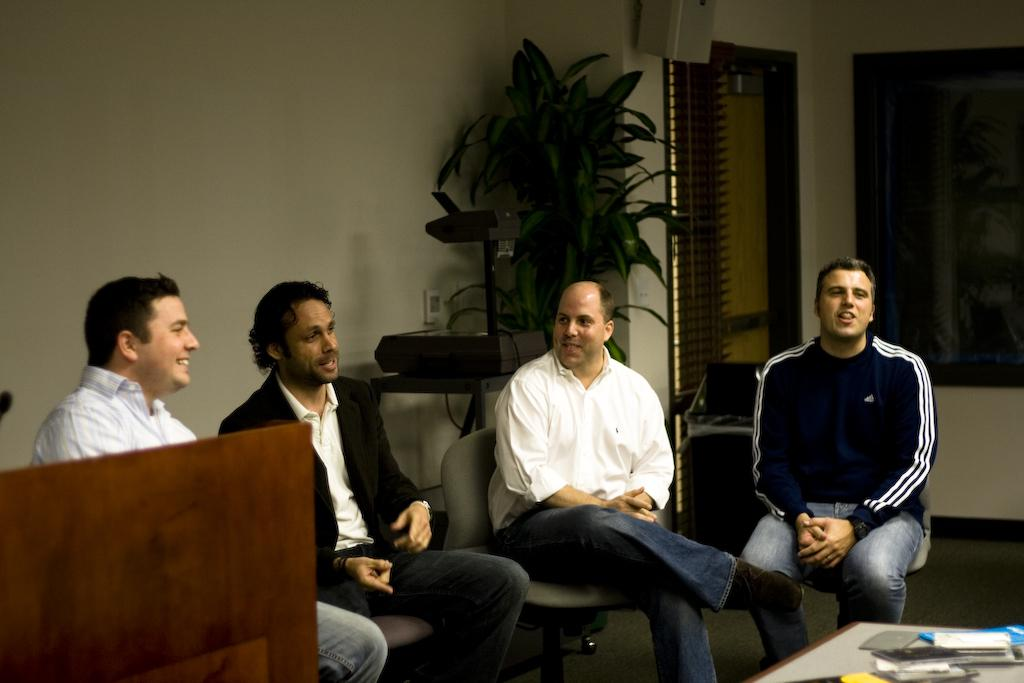How many men are present in the image? There are four men in the image. What are the men doing in the image? The men are sitting in chairs and talking to each other. What type of boats can be seen in the image? There are no boats present in the image; it features four men sitting in chairs and talking to each other. 